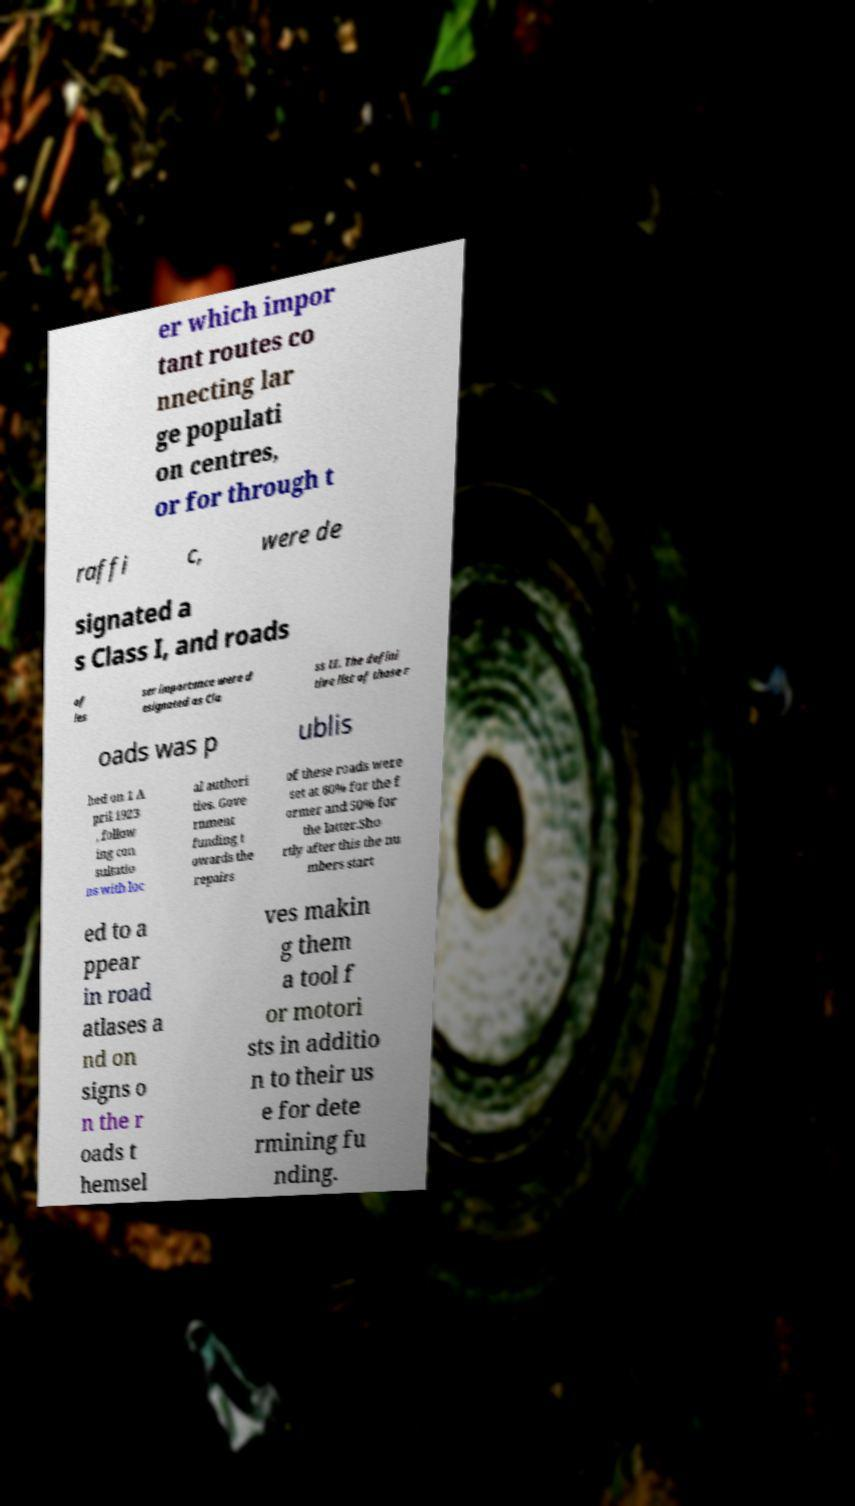Please read and relay the text visible in this image. What does it say? er which impor tant routes co nnecting lar ge populati on centres, or for through t raffi c, were de signated a s Class I, and roads of les ser importance were d esignated as Cla ss II. The defini tive list of those r oads was p ublis hed on 1 A pril 1923 , follow ing con sultatio ns with loc al authori ties. Gove rnment funding t owards the repairs of these roads were set at 60% for the f ormer and 50% for the latter.Sho rtly after this the nu mbers start ed to a ppear in road atlases a nd on signs o n the r oads t hemsel ves makin g them a tool f or motori sts in additio n to their us e for dete rmining fu nding. 